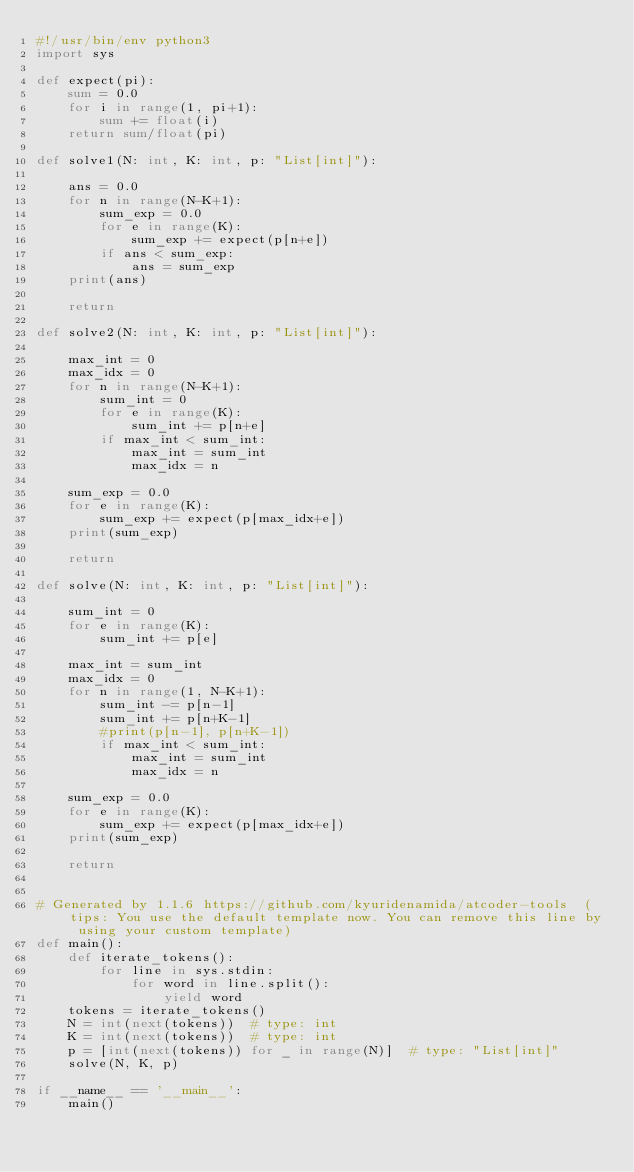Convert code to text. <code><loc_0><loc_0><loc_500><loc_500><_Python_>#!/usr/bin/env python3
import sys

def expect(pi):
    sum = 0.0
    for i in range(1, pi+1):
        sum += float(i)
    return sum/float(pi)

def solve1(N: int, K: int, p: "List[int]"):

    ans = 0.0
    for n in range(N-K+1):
        sum_exp = 0.0
        for e in range(K):
            sum_exp += expect(p[n+e])
        if ans < sum_exp:
            ans = sum_exp
    print(ans)

    return

def solve2(N: int, K: int, p: "List[int]"):

    max_int = 0
    max_idx = 0
    for n in range(N-K+1):
        sum_int = 0
        for e in range(K):
            sum_int += p[n+e]
        if max_int < sum_int:
            max_int = sum_int
            max_idx = n

    sum_exp = 0.0
    for e in range(K):
        sum_exp += expect(p[max_idx+e])
    print(sum_exp)

    return

def solve(N: int, K: int, p: "List[int]"):

    sum_int = 0
    for e in range(K):
        sum_int += p[e]

    max_int = sum_int
    max_idx = 0
    for n in range(1, N-K+1):
        sum_int -= p[n-1]
        sum_int += p[n+K-1]
        #print(p[n-1], p[n+K-1])
        if max_int < sum_int:
            max_int = sum_int
            max_idx = n

    sum_exp = 0.0
    for e in range(K):
        sum_exp += expect(p[max_idx+e])
    print(sum_exp)

    return


# Generated by 1.1.6 https://github.com/kyuridenamida/atcoder-tools  (tips: You use the default template now. You can remove this line by using your custom template)
def main():
    def iterate_tokens():
        for line in sys.stdin:
            for word in line.split():
                yield word
    tokens = iterate_tokens()
    N = int(next(tokens))  # type: int
    K = int(next(tokens))  # type: int
    p = [int(next(tokens)) for _ in range(N)]  # type: "List[int]"
    solve(N, K, p)

if __name__ == '__main__':
    main()
</code> 